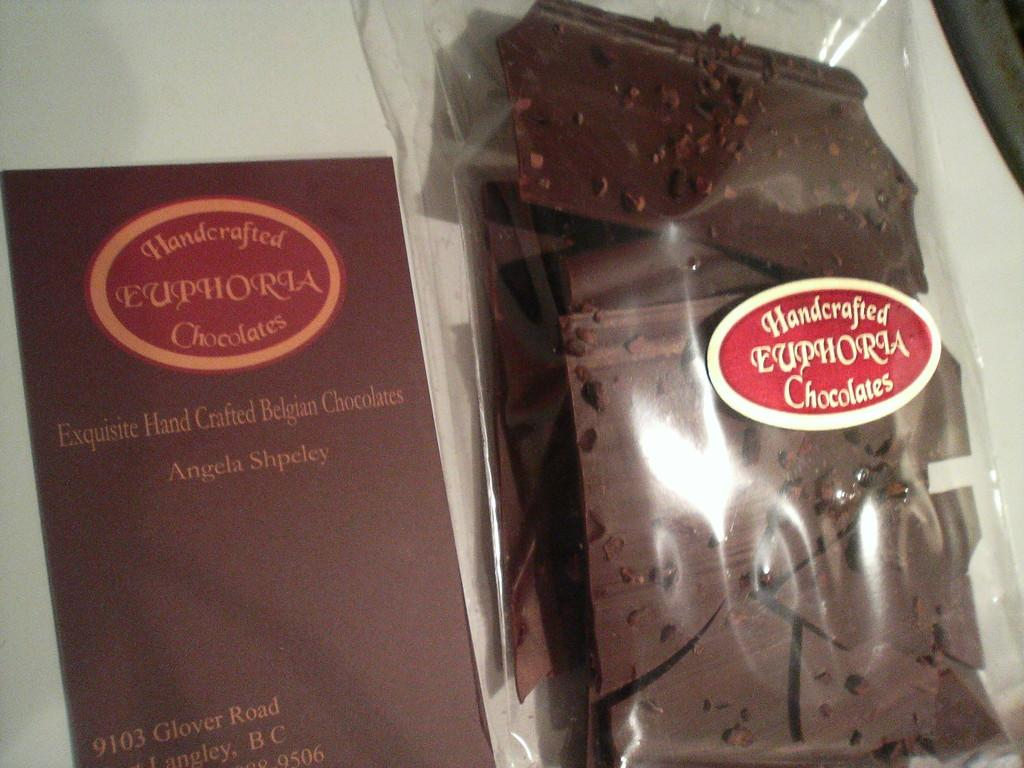<image>
Give a short and clear explanation of the subsequent image. A Euphoria brand chocolate product is in a plastic bag. 